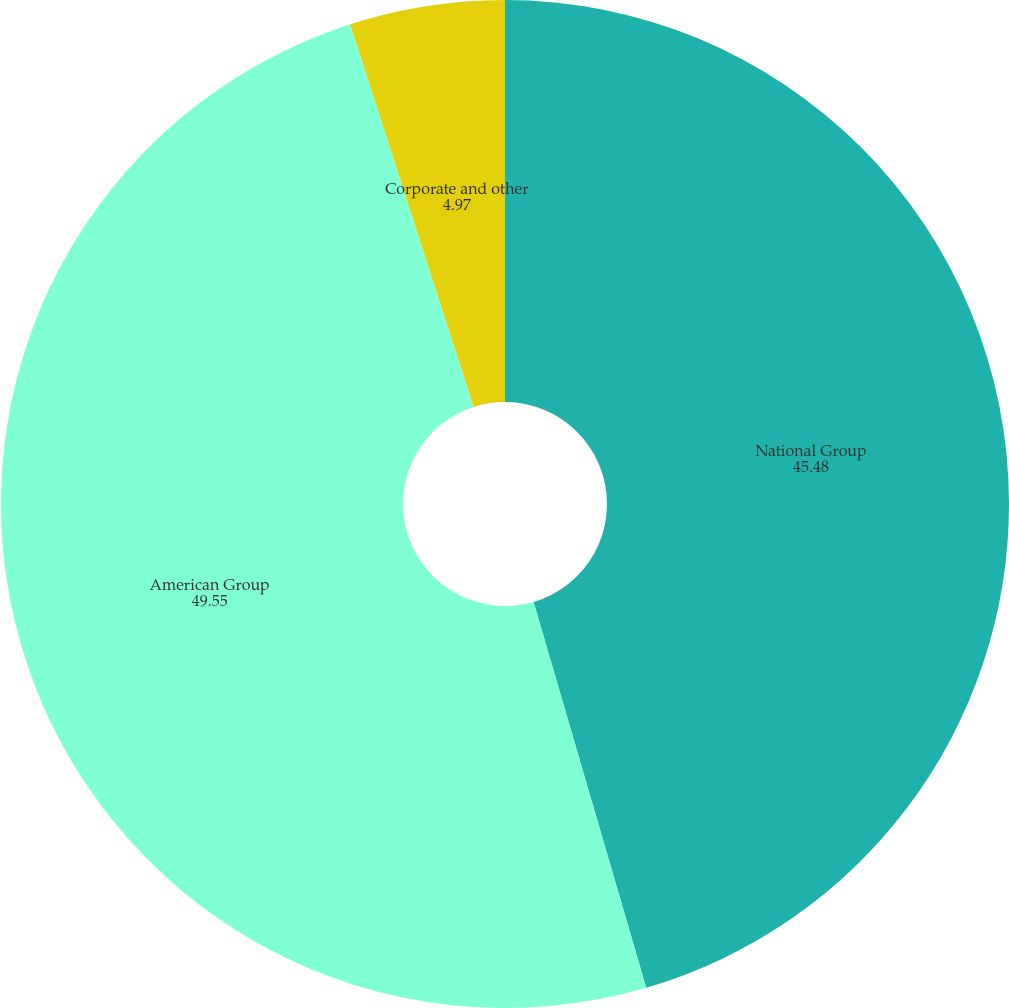<chart> <loc_0><loc_0><loc_500><loc_500><pie_chart><fcel>National Group<fcel>American Group<fcel>Corporate and other<nl><fcel>45.48%<fcel>49.55%<fcel>4.97%<nl></chart> 